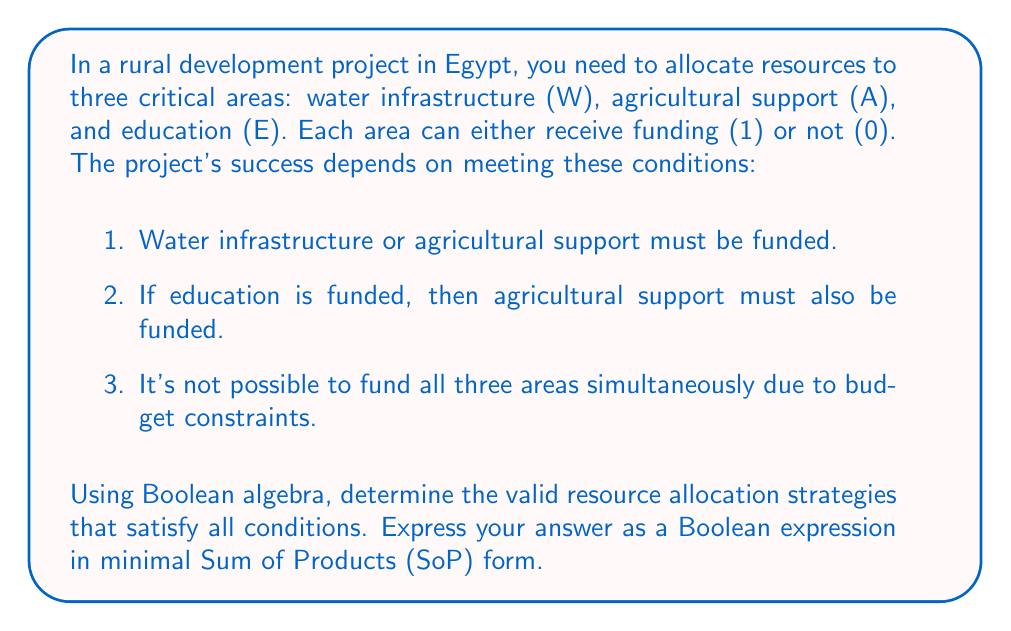Give your solution to this math problem. Let's approach this step-by-step using Boolean algebra:

1) First, let's translate the conditions into Boolean expressions:
   Condition 1: $W + A = 1$
   Condition 2: $E \rightarrow A$, which is equivalent to $\overline{E} + A = 1$
   Condition 3: $\overline{(W \cdot A \cdot E)} = 1$

2) Now, let's combine these conditions using the AND operation:
   $$(W + A) \cdot (\overline{E} + A) \cdot \overline{(W \cdot A \cdot E)} = 1$$

3) Expand the first two terms:
   $$(W\overline{E} + WA + A\overline{E} + A^2) \cdot \overline{(W \cdot A \cdot E)} = 1$$

4) Simplify $A^2$ to $A$ (idempotent law):
   $$(W\overline{E} + WA + A\overline{E} + A) \cdot \overline{(W \cdot A \cdot E)} = 1$$

5) Distribute the last term:
   $$W\overline{E}\overline{(W \cdot A \cdot E)} + WA\overline{(W \cdot A \cdot E)} + A\overline{E}\overline{(W \cdot A \cdot E)} + A\overline{(W \cdot A \cdot E)} = 1$$

6) Simplify each term:
   - $W\overline{E}\overline{(W \cdot A \cdot E)} = W\overline{E}$ (because $\overline{E}$ already ensures $\overline{(W \cdot A \cdot E)}$)
   - $WA\overline{(W \cdot A \cdot E)} = WA\overline{E}$
   - $A\overline{E}\overline{(W \cdot A \cdot E)} = A\overline{E}$
   - $A\overline{(W \cdot A \cdot E)} = A\overline{W} + A\overline{E}$

7) Combine like terms:
   $$W\overline{E} + WA\overline{E} + A\overline{E} + A\overline{W} = 1$$

8) This is already in SoP form, but we can minimize it further:
   $W\overline{E} + A\overline{E} + A\overline{W} = 1$

This is the minimal SoP form representing all valid resource allocation strategies.
Answer: $$W\overline{E} + A\overline{E} + A\overline{W}$$ 